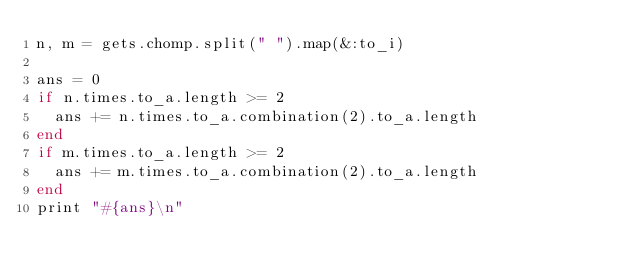<code> <loc_0><loc_0><loc_500><loc_500><_Ruby_>n, m = gets.chomp.split(" ").map(&:to_i)

ans = 0
if n.times.to_a.length >= 2
  ans += n.times.to_a.combination(2).to_a.length
end
if m.times.to_a.length >= 2
  ans += m.times.to_a.combination(2).to_a.length
end
print "#{ans}\n"</code> 